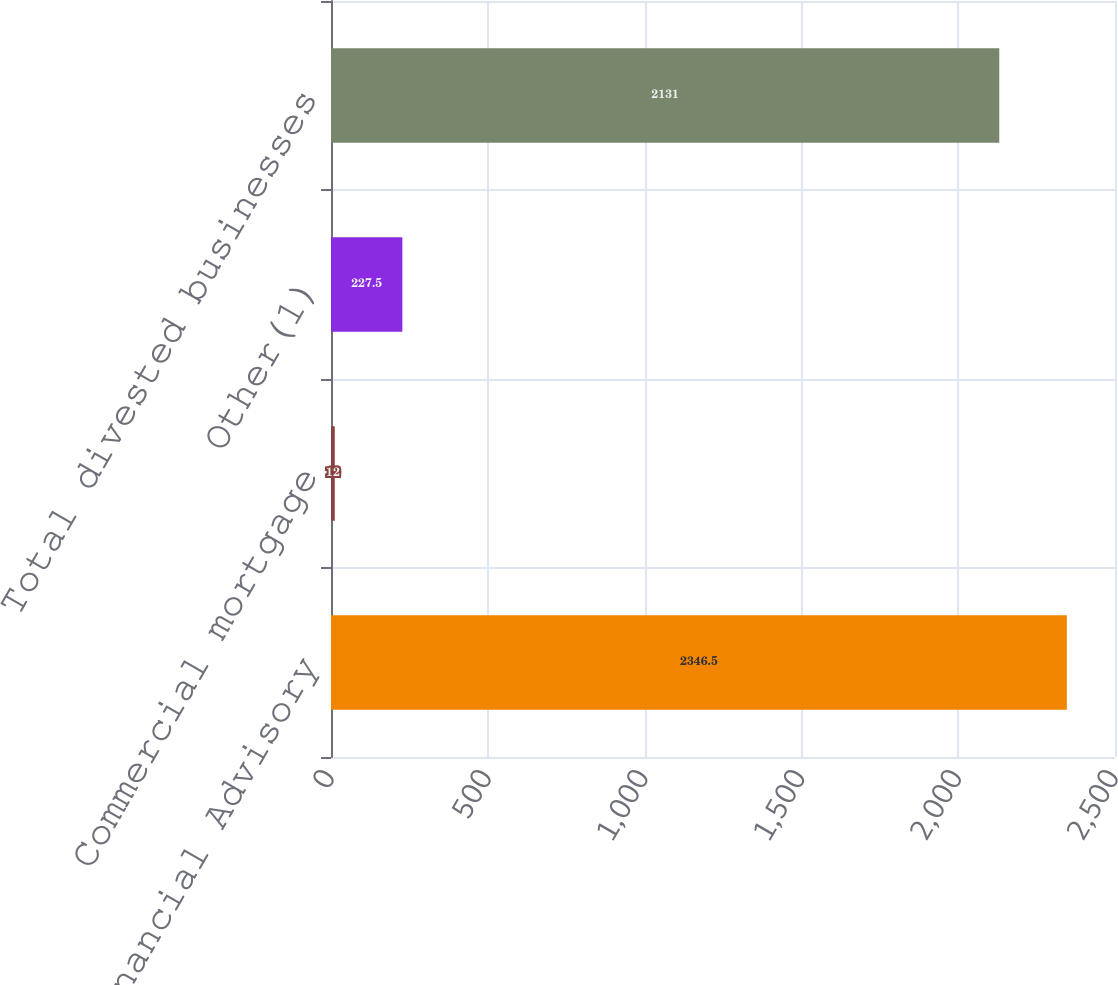Convert chart to OTSL. <chart><loc_0><loc_0><loc_500><loc_500><bar_chart><fcel>Financial Advisory<fcel>Commercial mortgage<fcel>Other(1)<fcel>Total divested businesses<nl><fcel>2346.5<fcel>12<fcel>227.5<fcel>2131<nl></chart> 